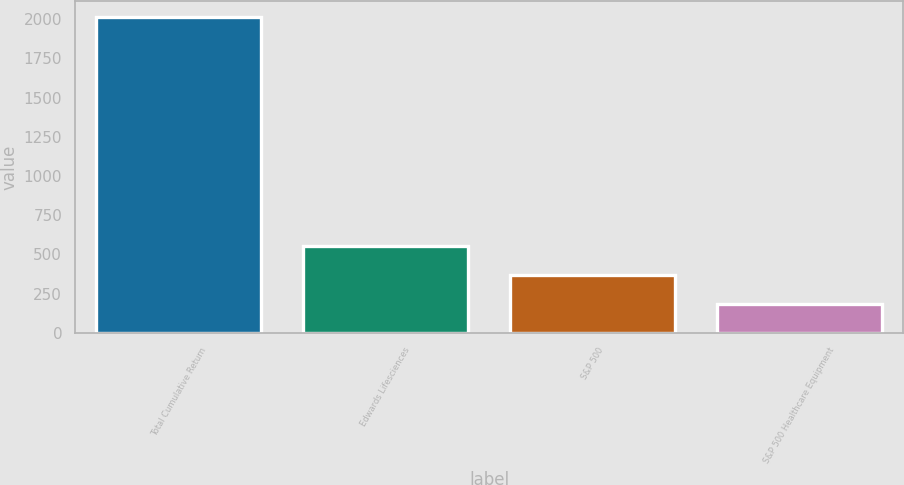<chart> <loc_0><loc_0><loc_500><loc_500><bar_chart><fcel>Total Cumulative Return<fcel>Edwards Lifesciences<fcel>S&P 500<fcel>S&P 500 Healthcare Equipment<nl><fcel>2013<fcel>551.4<fcel>368.7<fcel>186<nl></chart> 